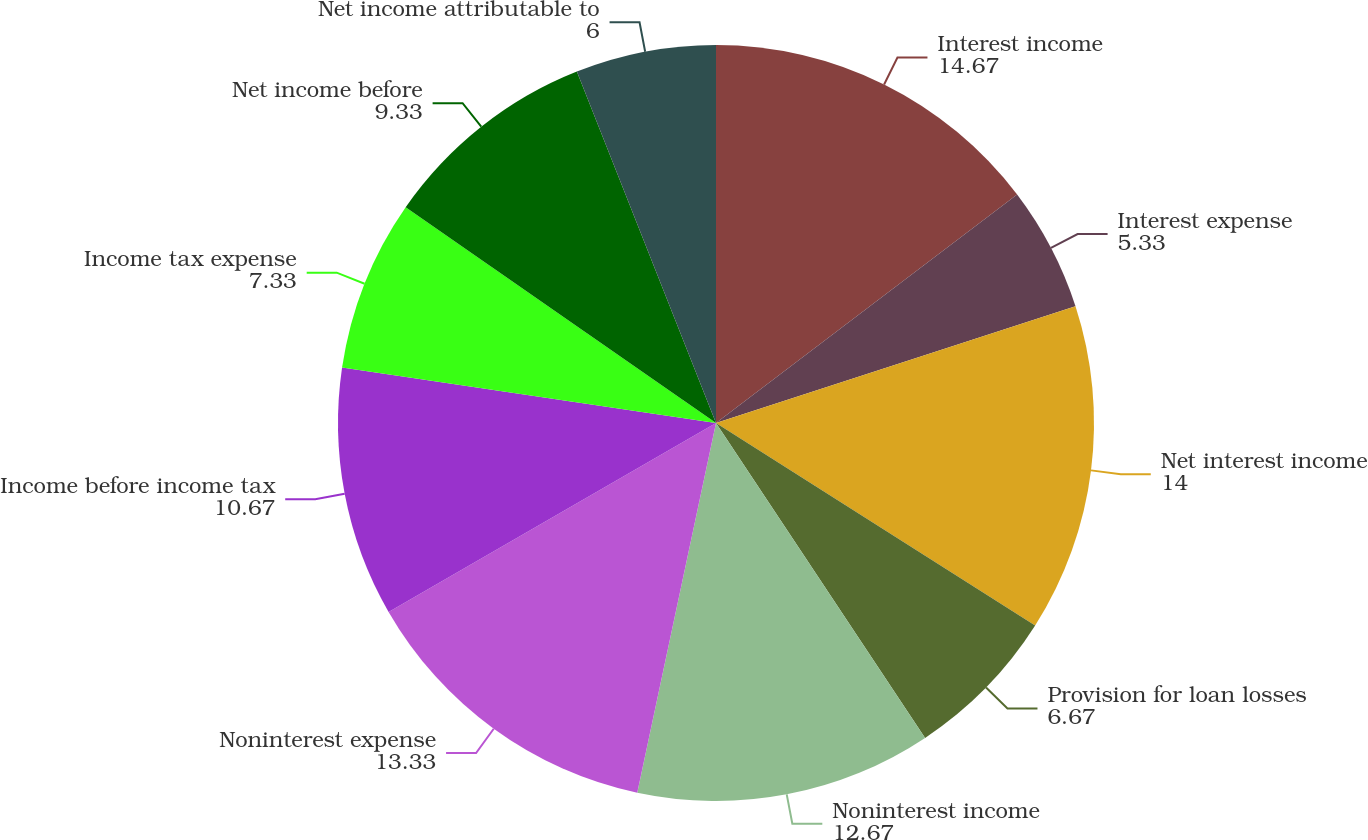Convert chart to OTSL. <chart><loc_0><loc_0><loc_500><loc_500><pie_chart><fcel>Interest income<fcel>Interest expense<fcel>Net interest income<fcel>Provision for loan losses<fcel>Noninterest income<fcel>Noninterest expense<fcel>Income before income tax<fcel>Income tax expense<fcel>Net income before<fcel>Net income attributable to<nl><fcel>14.67%<fcel>5.33%<fcel>14.0%<fcel>6.67%<fcel>12.67%<fcel>13.33%<fcel>10.67%<fcel>7.33%<fcel>9.33%<fcel>6.0%<nl></chart> 